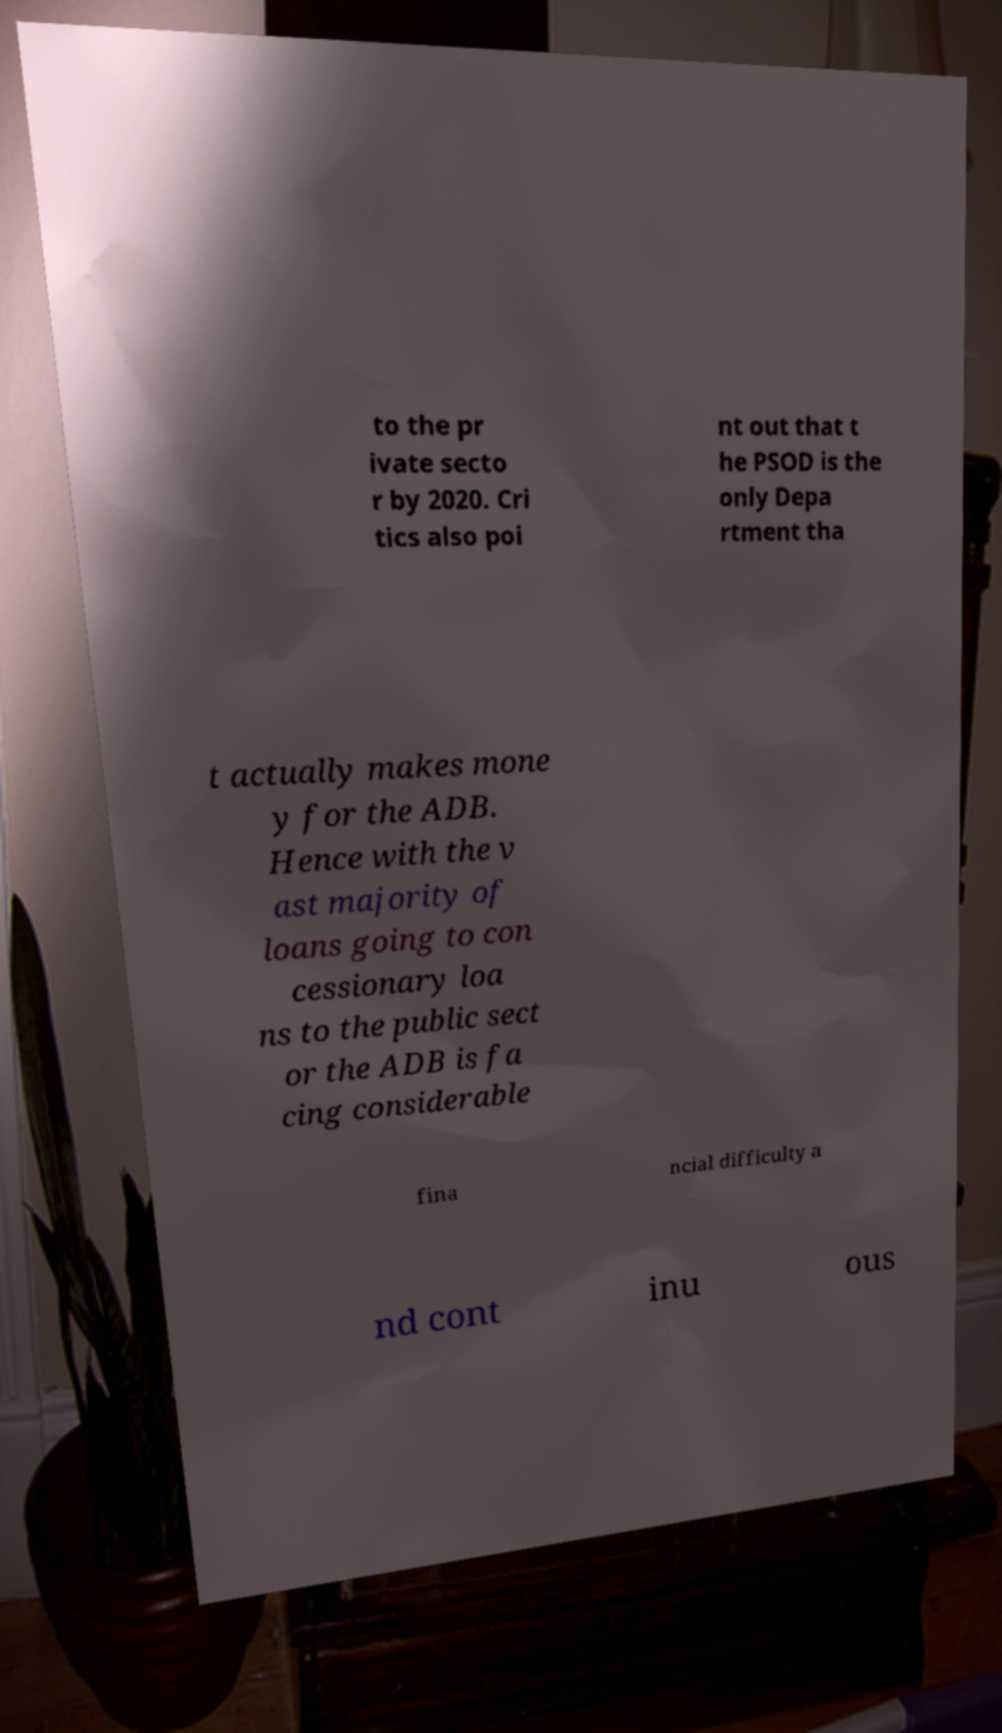Please read and relay the text visible in this image. What does it say? to the pr ivate secto r by 2020. Cri tics also poi nt out that t he PSOD is the only Depa rtment tha t actually makes mone y for the ADB. Hence with the v ast majority of loans going to con cessionary loa ns to the public sect or the ADB is fa cing considerable fina ncial difficulty a nd cont inu ous 